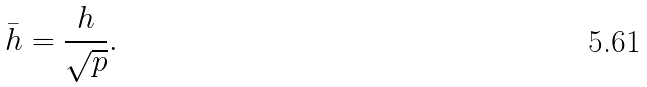Convert formula to latex. <formula><loc_0><loc_0><loc_500><loc_500>\bar { h } = \frac { h } { \sqrt { p } } .</formula> 